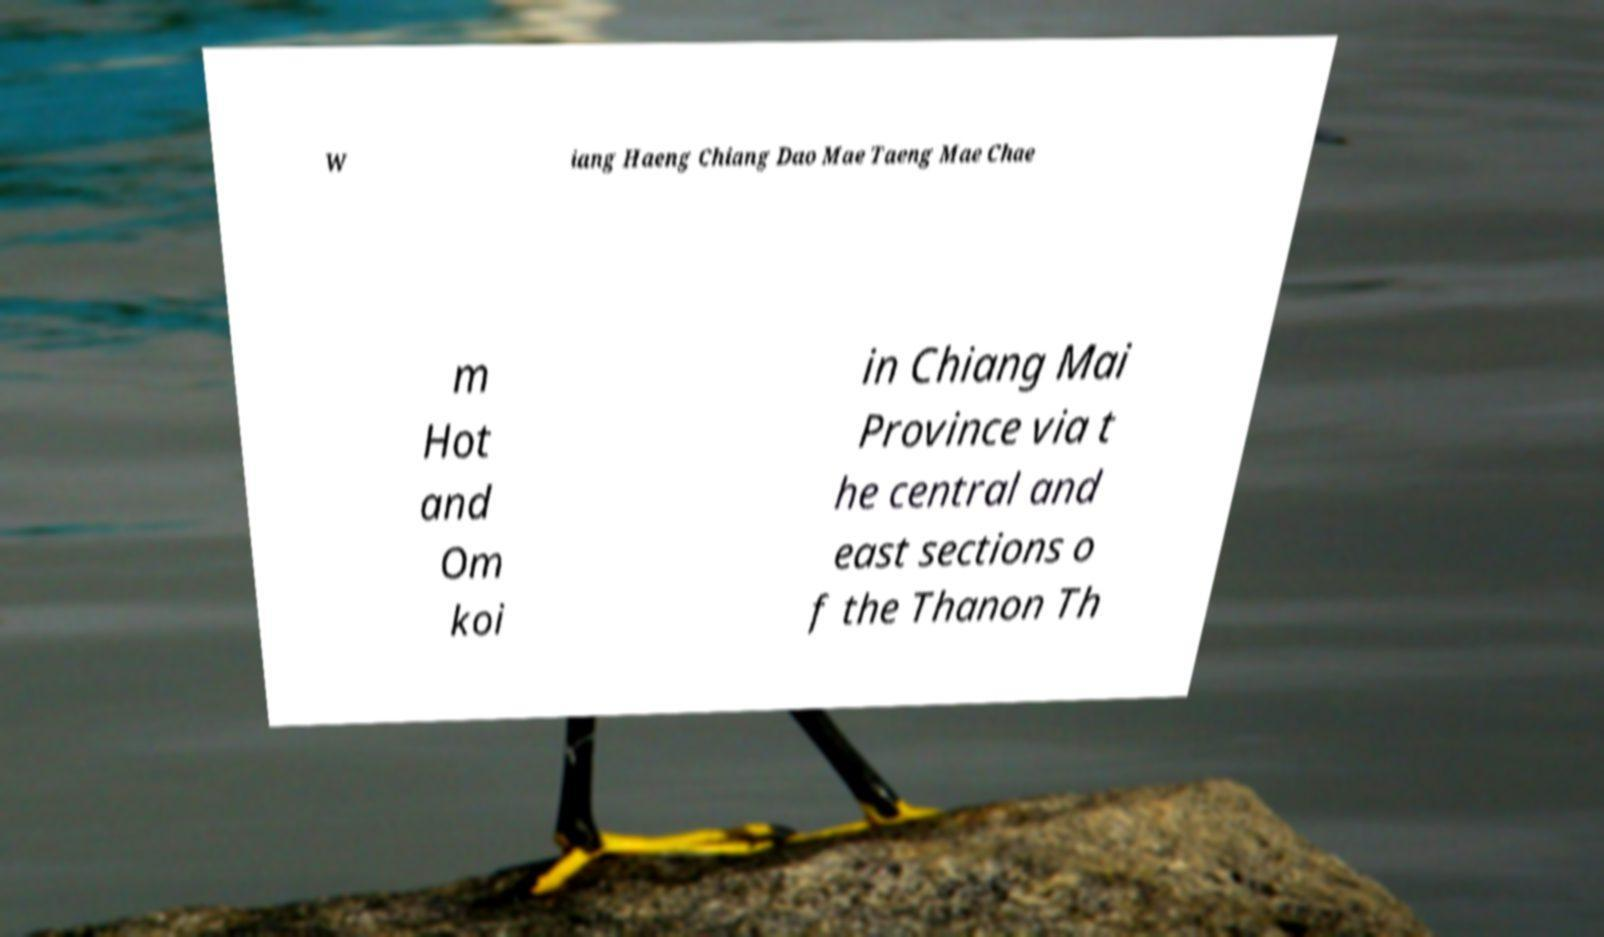For documentation purposes, I need the text within this image transcribed. Could you provide that? W iang Haeng Chiang Dao Mae Taeng Mae Chae m Hot and Om koi in Chiang Mai Province via t he central and east sections o f the Thanon Th 